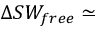<formula> <loc_0><loc_0><loc_500><loc_500>\Delta S W _ { f r e e } \simeq</formula> 